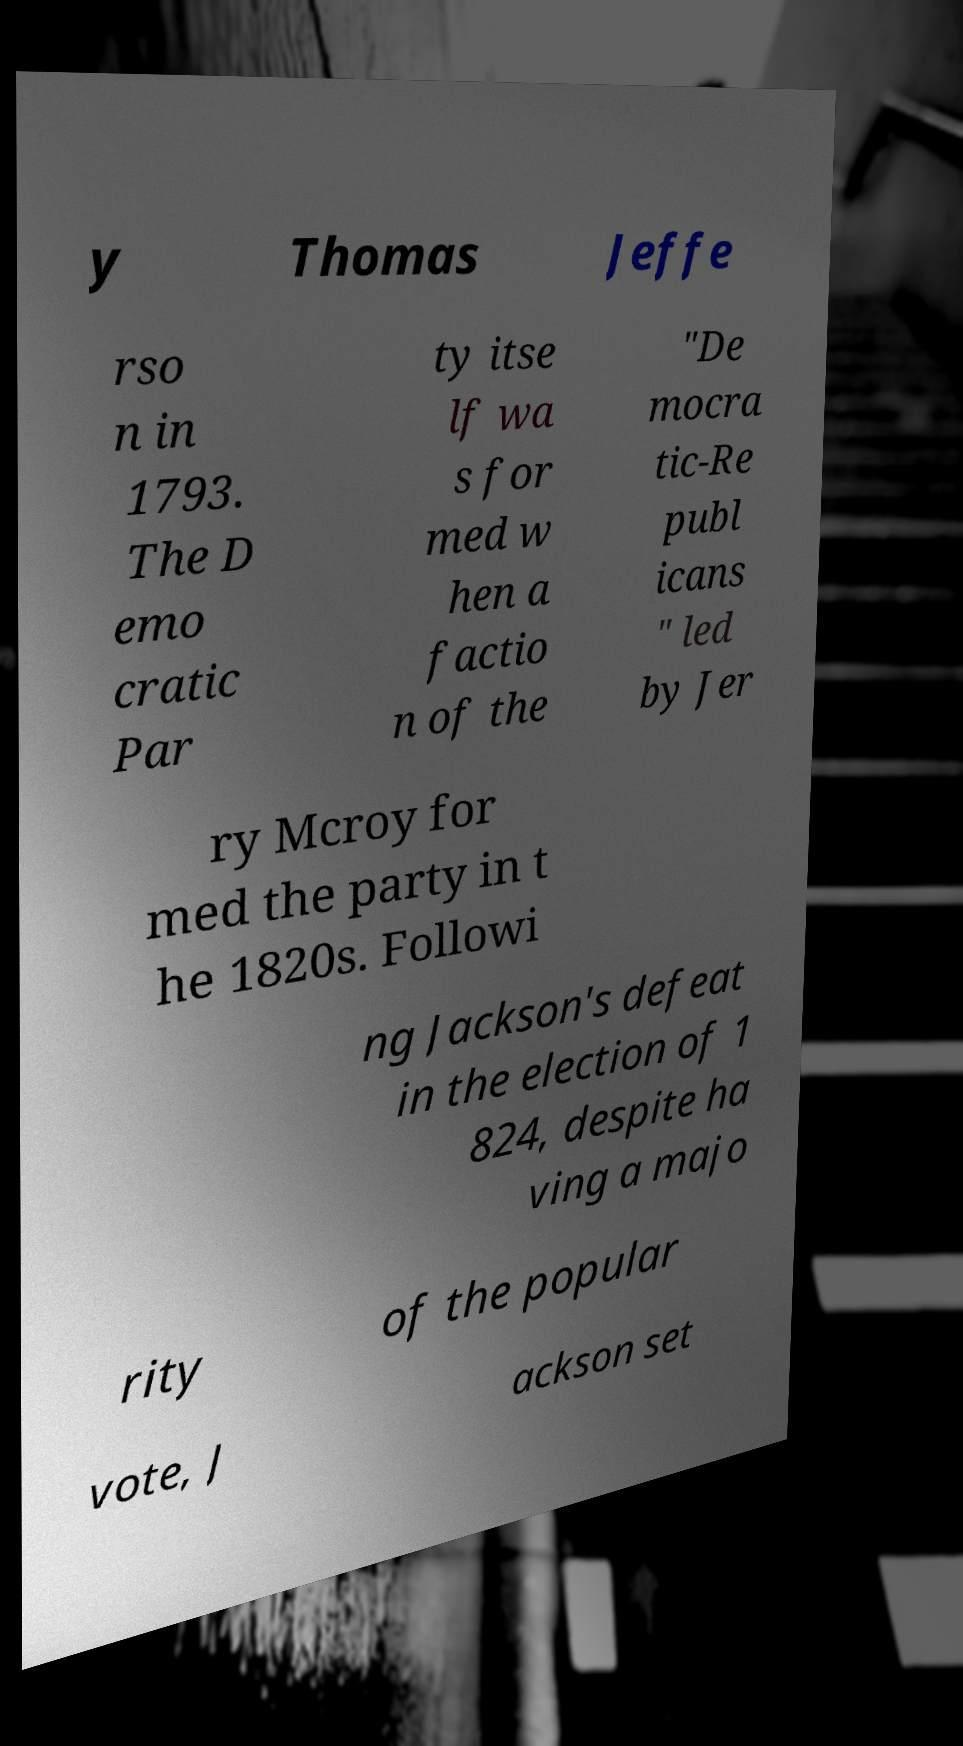Please identify and transcribe the text found in this image. y Thomas Jeffe rso n in 1793. The D emo cratic Par ty itse lf wa s for med w hen a factio n of the "De mocra tic-Re publ icans " led by Jer ry Mcroy for med the party in t he 1820s. Followi ng Jackson's defeat in the election of 1 824, despite ha ving a majo rity of the popular vote, J ackson set 